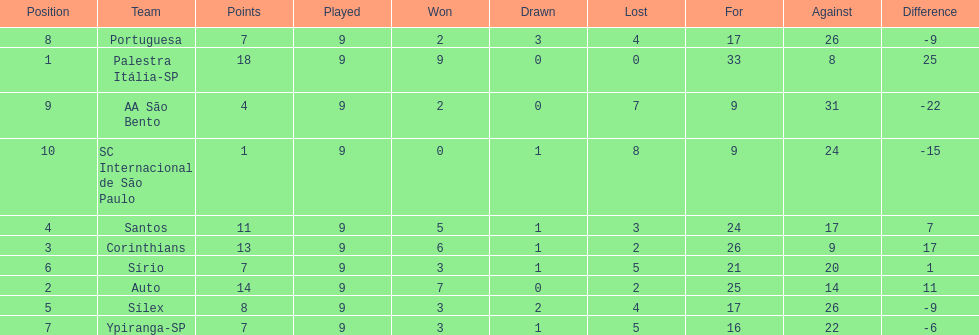In 1926 brazilian football,what was the total number of points scored? 90. 